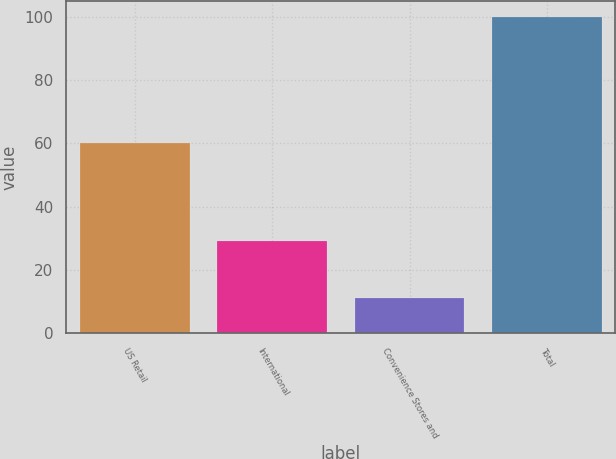Convert chart to OTSL. <chart><loc_0><loc_0><loc_500><loc_500><bar_chart><fcel>US Retail<fcel>International<fcel>Convenience Stores and<fcel>Total<nl><fcel>60<fcel>29<fcel>11<fcel>100<nl></chart> 